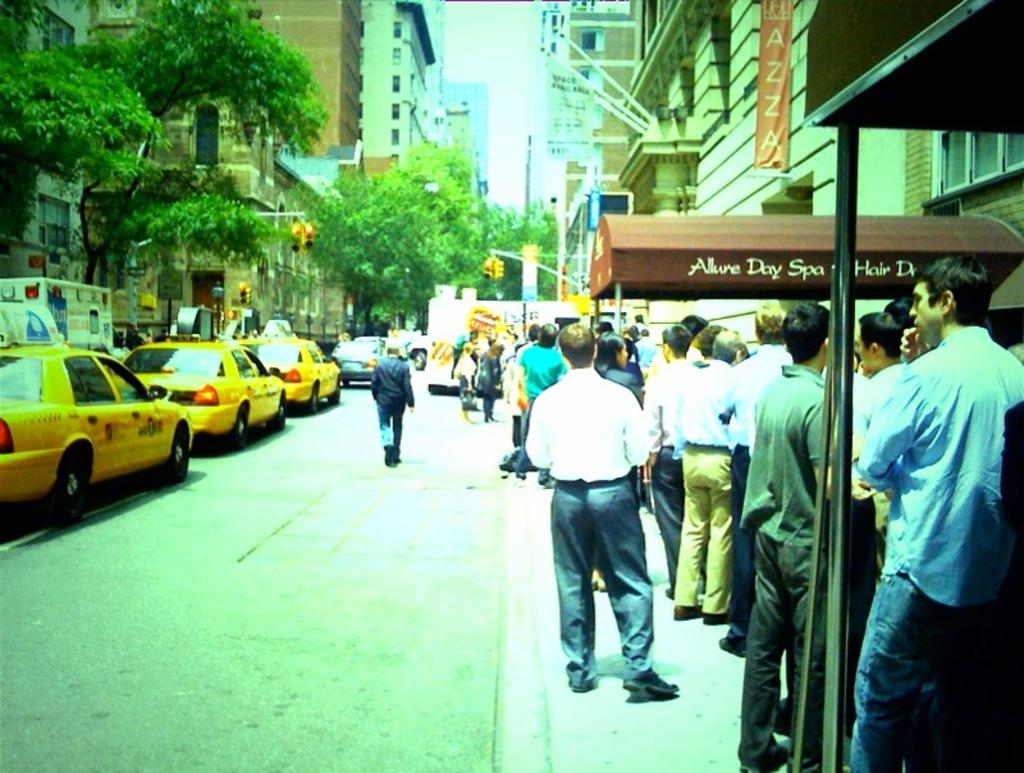Provide a one-sentence caption for the provided image. A crowd lines a sidewalk where the Allure Day Spa is located. 